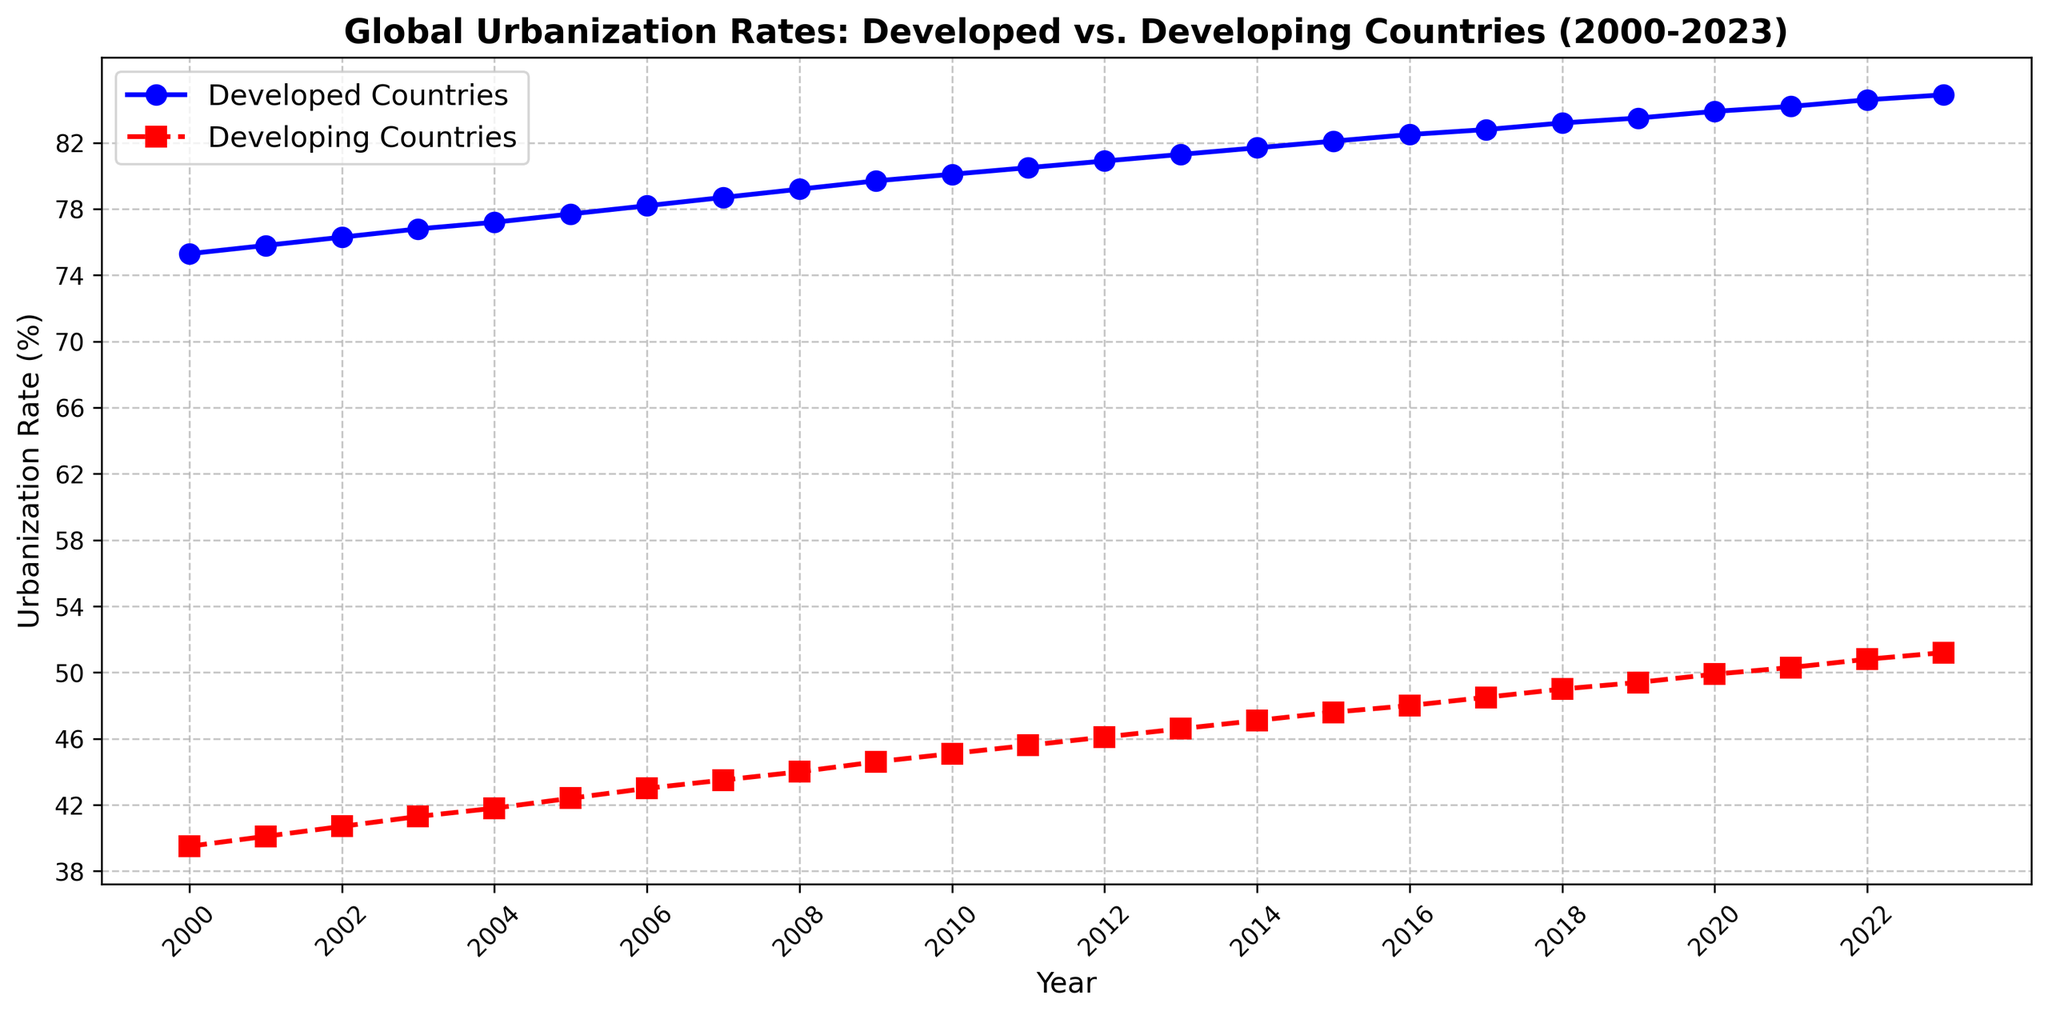What is the overall trend in urbanization rates for developing countries from 2000 to 2023? The urbanization rate for developing countries shows a consistent increasing trend from 39.5% in 2000 to 51.2% in 2023.
Answer: Increasing In which year did the urbanization rate in developing countries surpass 50%? By examining the chart, we can see that the urbanization rate in developing countries surpassed 50% in the year 2021.
Answer: 2021 How much did the urbanization rate increase in developed countries from 2000 to 2023? To find the increase, subtract the rate in 2000 (75.3%) from the rate in 2023 (84.9%). The increase is 84.9% - 75.3% = 9.6%.
Answer: 9.6% Which countries had a higher urbanization rate in 2010 and by how much? In 2010, developed countries had an urbanization rate of 80.1%, while developing countries had 45.1%. The difference is 80.1% - 45.1% = 35%.
Answer: Developed countries by 35% What is the difference in urbanization rates between the two groups in 2023? In 2023, urbanization rates are 84.9% for developed countries and 51.2% for developing countries. The difference is 84.9% - 51.2% = 33.7%.
Answer: 33.7% What is the median urbanization rate for developing countries from 2000 to 2023? Arrange the urbanization rates for developing countries in order: 39.5, 40.1, 40.7, 41.3, 41.8, 42.4, 43.0, 43.5, 44.0, 44.6, 45.1, 45.6, 46.1, 46.6, 47.1, 47.6, 48.0, 48.5, 49.0, 49.4, 49.9, 50.3, 50.8, 51.2. The median is the middle value: 45.6%.
Answer: 45.6% Between which years did developed countries achieve the most noticeable annual increase in urbanization rate? The largest annual increase for developed countries occurs between 2004 and 2005 where the rate increases from 77.2% to 77.7%, a difference of 0.5%.
Answer: 2004-2005 What was the urbanization rate trend in both developed and developing countries during the last five years (2019-2023)? From 2019 to 2023, both developed countries' urbanization rate increased from 83.5% to 84.9% and developing countries' rate increased from 49.4% to 51.2%. Both groups show a steady increase.
Answer: Steady increase What visual elements indicate differentiation between developed and developing countries' urbanization rates on the line chart? The developed countries' line is represented by blue circles with solid lines, while developing countries' line uses red squares with dashed lines.
Answer: Line styles and colors 